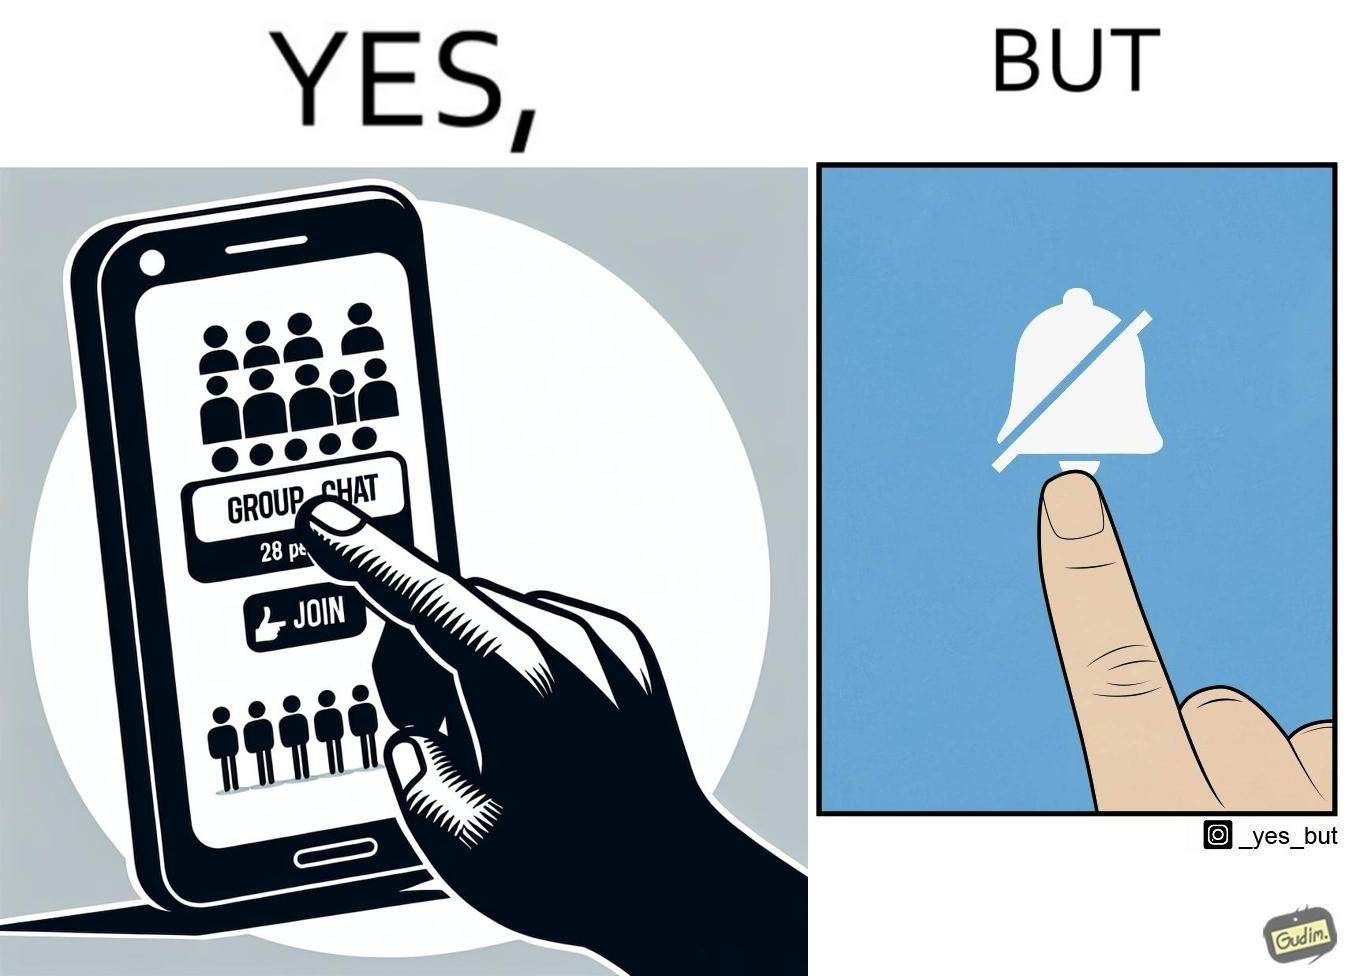What does this image depict? This is ironic because the person joining the big social group, presumably interested in the happenings of that group, motivated to engage with these people, MUTEs the group as soon as they join it, indicating they are not interested in it and do not  want to be bothered by it.  These actions are contradictory from a social perspective, and illuminate a weird fact about present day online life. 